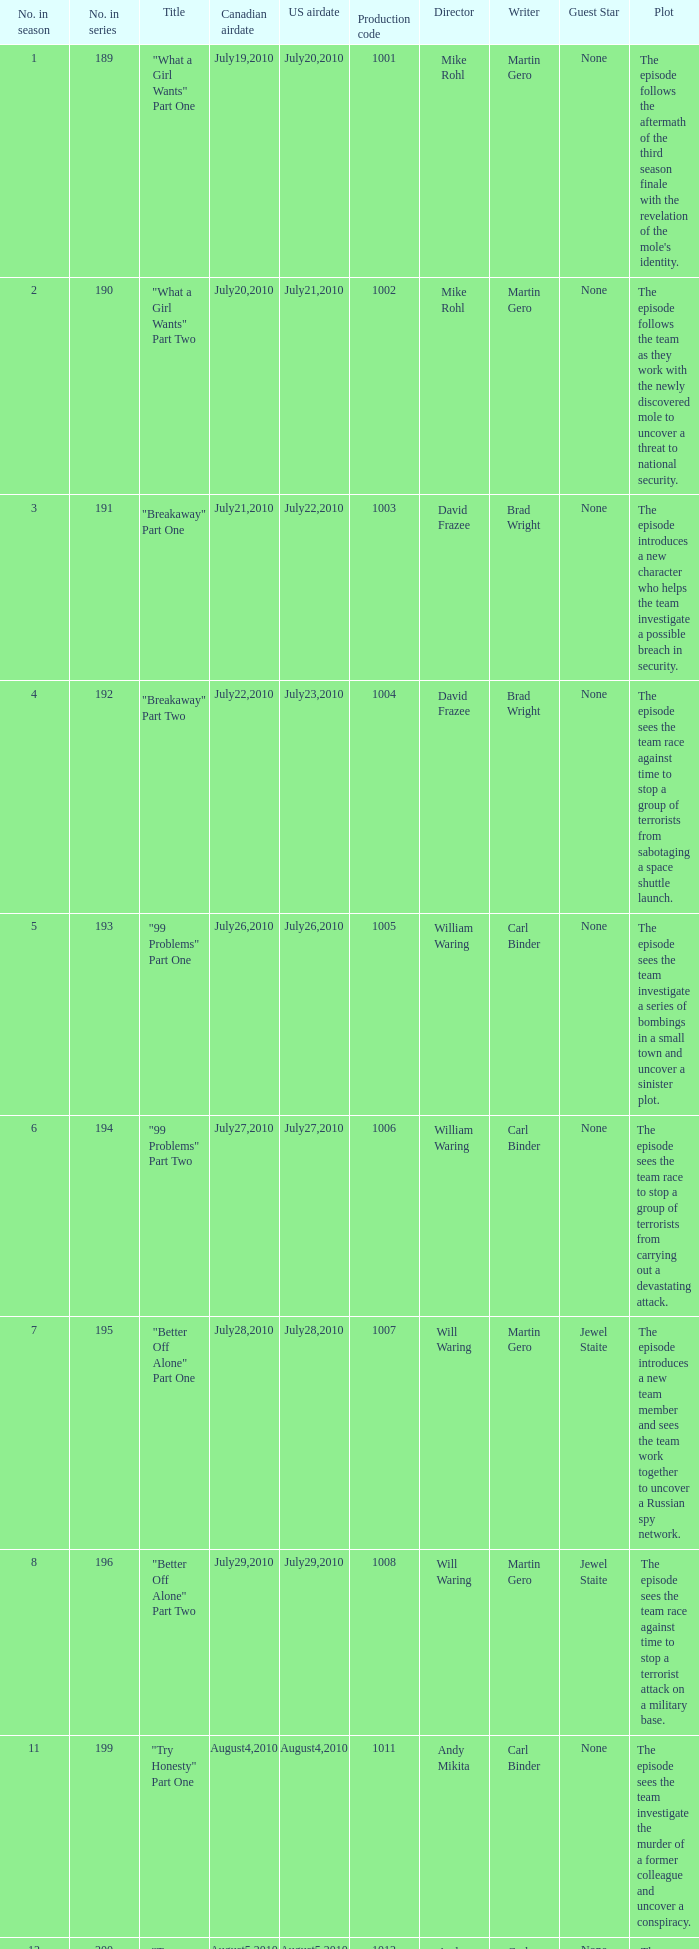How many titles had production code 1040? 1.0. 